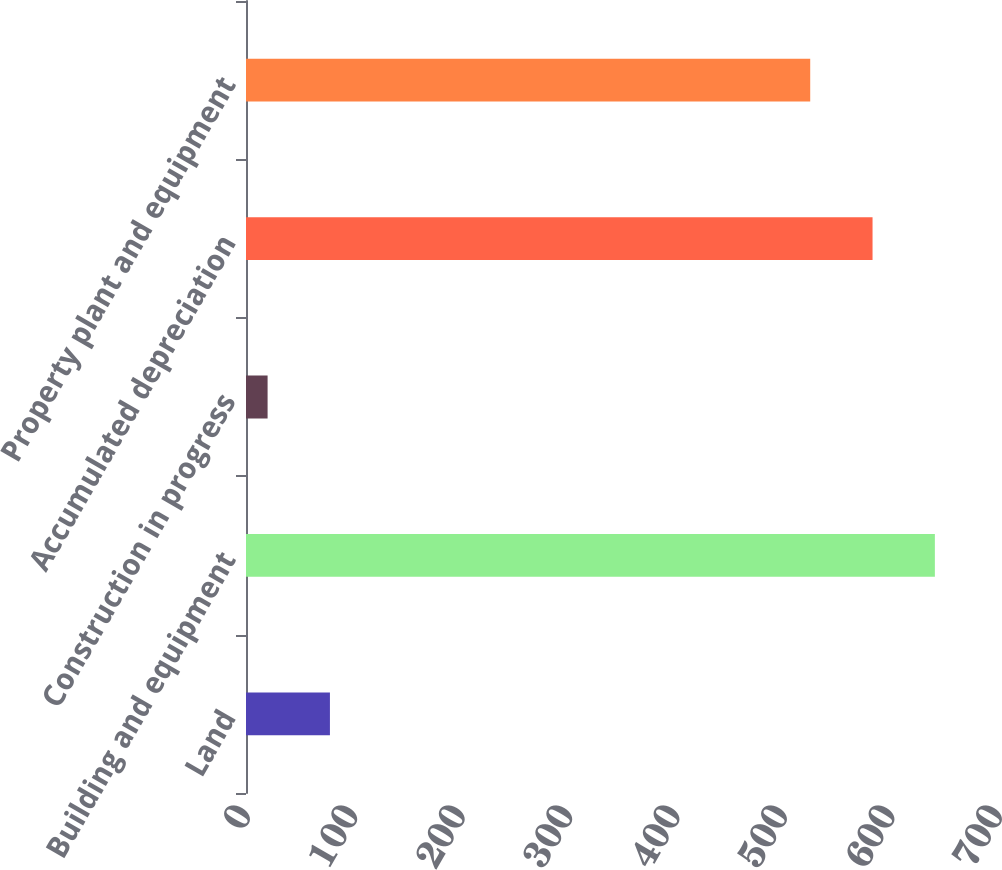Convert chart. <chart><loc_0><loc_0><loc_500><loc_500><bar_chart><fcel>Land<fcel>Building and equipment<fcel>Construction in progress<fcel>Accumulated depreciation<fcel>Property plant and equipment<nl><fcel>78.12<fcel>641.24<fcel>20.1<fcel>583.22<fcel>525.2<nl></chart> 